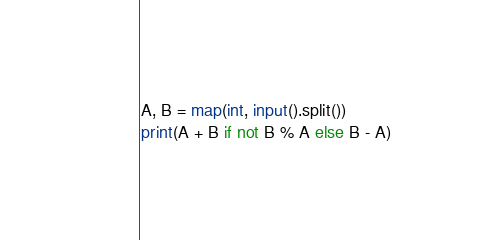Convert code to text. <code><loc_0><loc_0><loc_500><loc_500><_Python_>A, B = map(int, input().split())
print(A + B if not B % A else B - A)</code> 